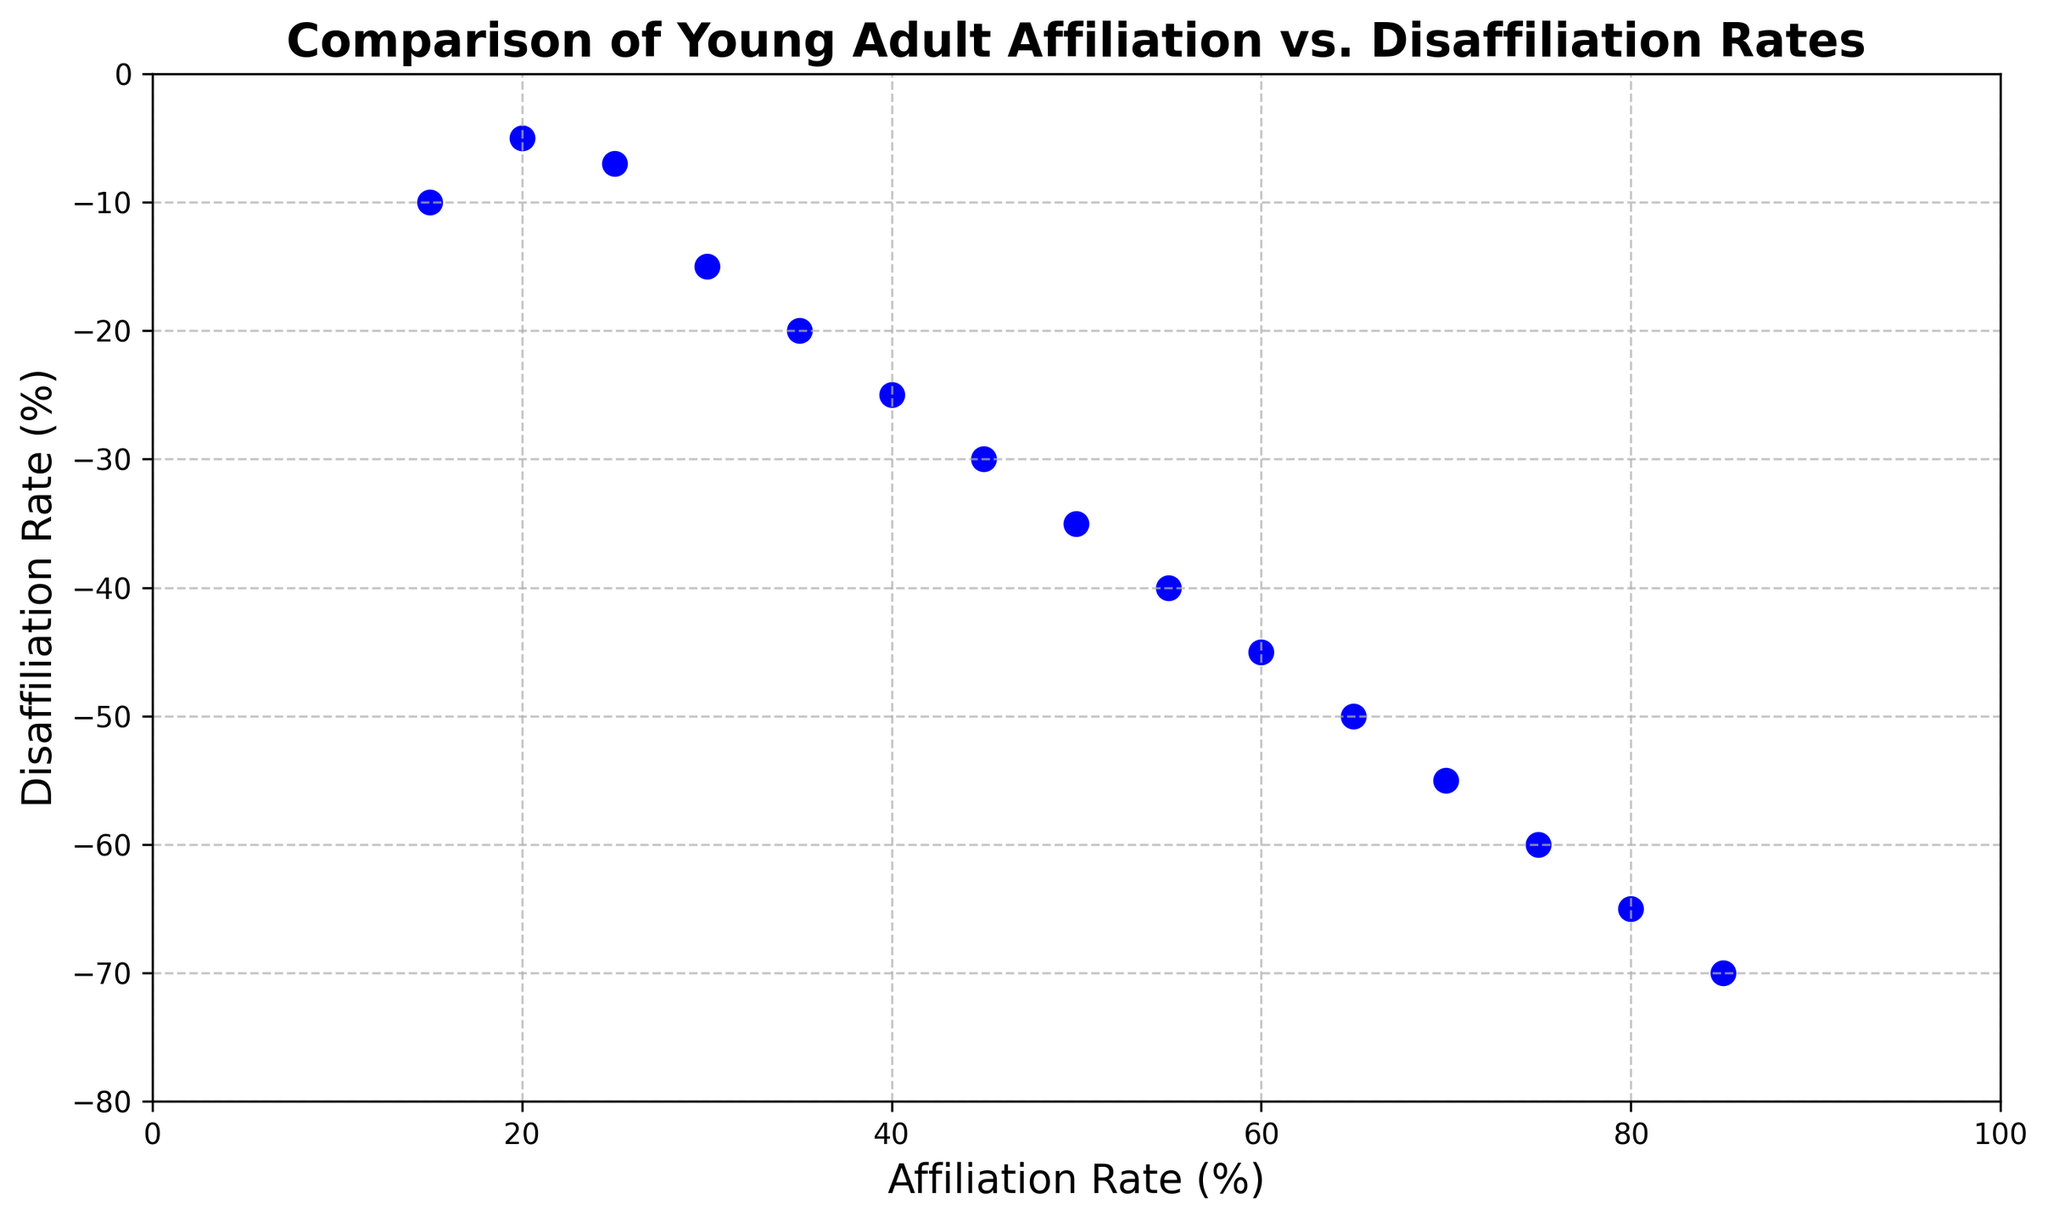What is the affiliation rate when the disaffiliation rate is -25? Find the data point in the scatter plot where the disaffiliation rate is -25. The corresponding value on the x-axis will be the affiliation rate.
Answer: 40% Which affiliation rate corresponds to the highest disaffiliation rate? Locate the data point with the most negative disaffiliation rate (-70) on the y-axis. The corresponding value on the x-axis gives the affiliation rate.
Answer: 85% Is there a data point where the affiliation rate is 55%? Check the scatter plot for a data point at 55% on the x-axis. If present, note the y-axis value for the disaffiliation rate at that point.
Answer: Yes, the disaffiliation rate is -40% Between affiliation rates of 25% and 35%, who has a higher disaffiliation rate? Compare the disaffiliation rates at 25% and 35% affiliation rates (-7 and -20, respectively).
Answer: 35% What is the average disaffiliation rate for affiliation rates of 20% and 80%? Locate disaffiliation rates at 20% and 80% affiliation rates (-5 and -65, respectively), then find their average: (-5 + -65) / 2 = -35.
Answer: -35 Does a higher affiliation rate correspond to a more negative disaffiliation rate? Observe the general trend in the scatter plot. As the affiliation rate increases along the x-axis, the disaffiliation rate values become more negative.
Answer: Yes What is the difference in disaffiliation rates between the lowest and highest affiliation rates? Identify disaffiliation rates at the lowest (20%) and highest (85%) affiliation rates (-5 and -70, respectively). Calculate the difference: -70 - (-5) = -65.
Answer: -65 What is the median disaffiliation rate? List all disaffiliation rates (-5, -7, -10, -15, -20, -25, -30, -35, -40, -45, -50, -55, -60, -65, -70) and find the middle value, which is -35.
Answer: -35 Which data point lies closest to the axis intersection point? The axis intersection is at (0, 0). The closest data point is either the one with the smallest affiliation rate or the smallest absolute disaffiliation rate. Check both axes to find the closest, which is at (20, -5).
Answer: (20%, -5%) Do any data points fall exactly on the grid lines? Check the scatter plot to observe if any points lie precisely on the grid lines, where values are typically rounded. Identify such points if they exist.
Answer: Yes, for example, (50%, -35%) falls on grid lines 